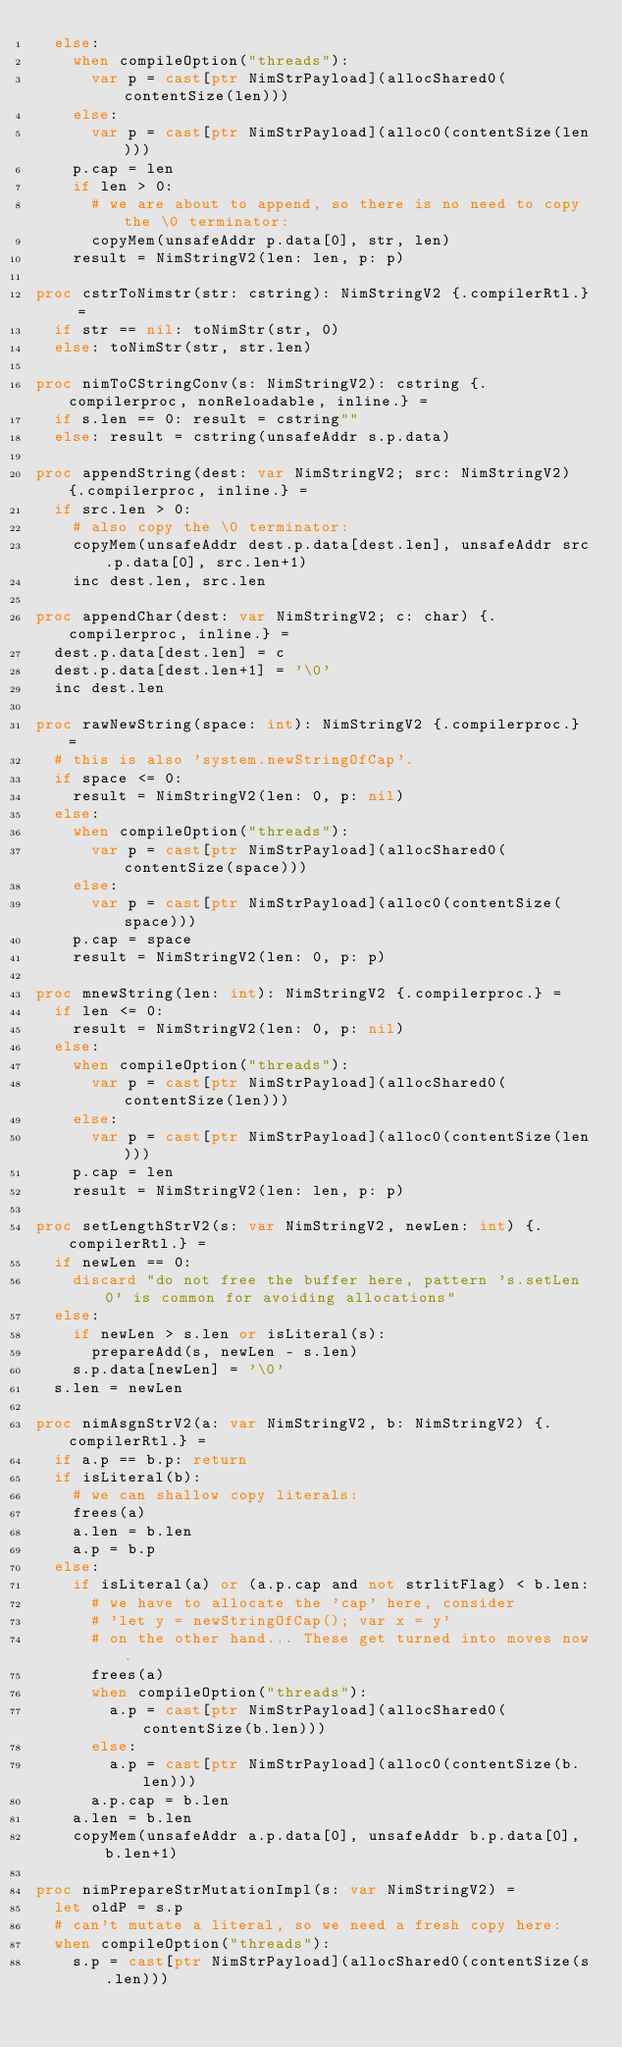Convert code to text. <code><loc_0><loc_0><loc_500><loc_500><_Nim_>  else:
    when compileOption("threads"):
      var p = cast[ptr NimStrPayload](allocShared0(contentSize(len)))
    else:
      var p = cast[ptr NimStrPayload](alloc0(contentSize(len)))
    p.cap = len
    if len > 0:
      # we are about to append, so there is no need to copy the \0 terminator:
      copyMem(unsafeAddr p.data[0], str, len)
    result = NimStringV2(len: len, p: p)

proc cstrToNimstr(str: cstring): NimStringV2 {.compilerRtl.} =
  if str == nil: toNimStr(str, 0)
  else: toNimStr(str, str.len)

proc nimToCStringConv(s: NimStringV2): cstring {.compilerproc, nonReloadable, inline.} =
  if s.len == 0: result = cstring""
  else: result = cstring(unsafeAddr s.p.data)

proc appendString(dest: var NimStringV2; src: NimStringV2) {.compilerproc, inline.} =
  if src.len > 0:
    # also copy the \0 terminator:
    copyMem(unsafeAddr dest.p.data[dest.len], unsafeAddr src.p.data[0], src.len+1)
    inc dest.len, src.len

proc appendChar(dest: var NimStringV2; c: char) {.compilerproc, inline.} =
  dest.p.data[dest.len] = c
  dest.p.data[dest.len+1] = '\0'
  inc dest.len

proc rawNewString(space: int): NimStringV2 {.compilerproc.} =
  # this is also 'system.newStringOfCap'.
  if space <= 0:
    result = NimStringV2(len: 0, p: nil)
  else:
    when compileOption("threads"):
      var p = cast[ptr NimStrPayload](allocShared0(contentSize(space)))
    else:
      var p = cast[ptr NimStrPayload](alloc0(contentSize(space)))
    p.cap = space
    result = NimStringV2(len: 0, p: p)

proc mnewString(len: int): NimStringV2 {.compilerproc.} =
  if len <= 0:
    result = NimStringV2(len: 0, p: nil)
  else:
    when compileOption("threads"):
      var p = cast[ptr NimStrPayload](allocShared0(contentSize(len)))
    else:
      var p = cast[ptr NimStrPayload](alloc0(contentSize(len)))
    p.cap = len
    result = NimStringV2(len: len, p: p)

proc setLengthStrV2(s: var NimStringV2, newLen: int) {.compilerRtl.} =
  if newLen == 0:
    discard "do not free the buffer here, pattern 's.setLen 0' is common for avoiding allocations"
  else:
    if newLen > s.len or isLiteral(s):
      prepareAdd(s, newLen - s.len)
    s.p.data[newLen] = '\0'
  s.len = newLen

proc nimAsgnStrV2(a: var NimStringV2, b: NimStringV2) {.compilerRtl.} =
  if a.p == b.p: return
  if isLiteral(b):
    # we can shallow copy literals:
    frees(a)
    a.len = b.len
    a.p = b.p
  else:
    if isLiteral(a) or (a.p.cap and not strlitFlag) < b.len:
      # we have to allocate the 'cap' here, consider
      # 'let y = newStringOfCap(); var x = y'
      # on the other hand... These get turned into moves now.
      frees(a)
      when compileOption("threads"):
        a.p = cast[ptr NimStrPayload](allocShared0(contentSize(b.len)))
      else:
        a.p = cast[ptr NimStrPayload](alloc0(contentSize(b.len)))
      a.p.cap = b.len
    a.len = b.len
    copyMem(unsafeAddr a.p.data[0], unsafeAddr b.p.data[0], b.len+1)

proc nimPrepareStrMutationImpl(s: var NimStringV2) =
  let oldP = s.p
  # can't mutate a literal, so we need a fresh copy here:
  when compileOption("threads"):
    s.p = cast[ptr NimStrPayload](allocShared0(contentSize(s.len)))</code> 